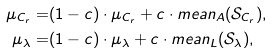Convert formula to latex. <formula><loc_0><loc_0><loc_500><loc_500>\mu _ { C _ { r } } = & ( 1 - c ) \cdot \mu _ { C _ { r } } + c \cdot m e a n _ { A } ( \mathcal { S } _ { C _ { r } } ) , \\ \mu _ { \lambda } = & ( 1 - c ) \cdot \mu _ { \lambda } + c \cdot m e a n _ { L } ( \mathcal { S } _ { \lambda } ) ,</formula> 